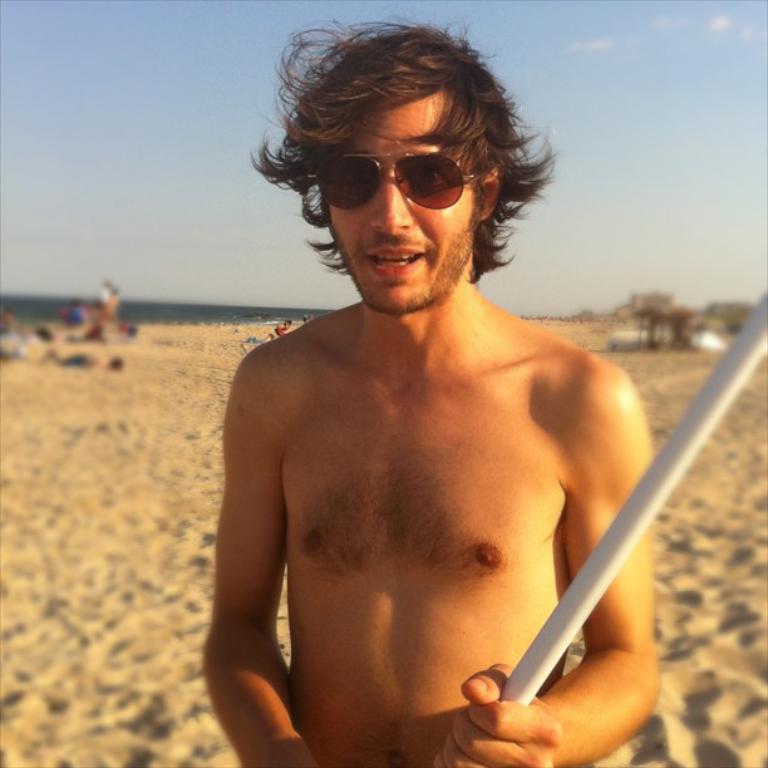Can you describe this image briefly? In this image, we can see a person is holding a rod and wearing goggles. Background there is a blur view. Here we can see few people, sand and sky. 